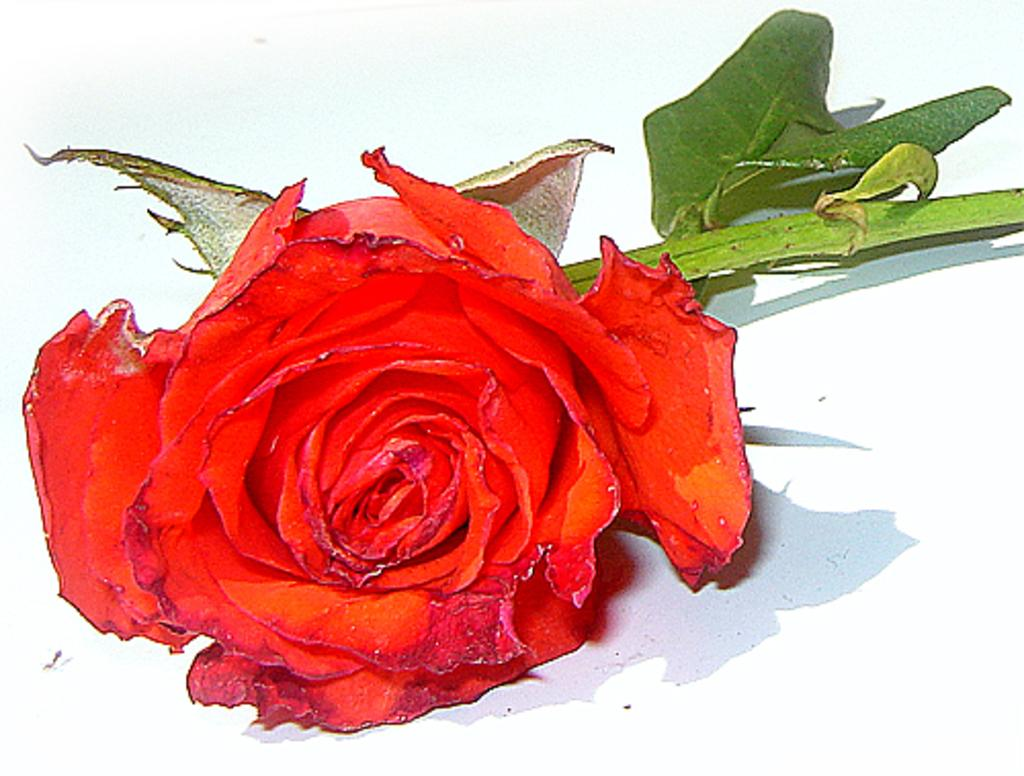What type of flower is in the image? There is a red rose in the image. What color are the leaves in the image? The leaves in the image are green. What connects the flower and leaves in the image? There is a stem in the image. What is the purpose of the glass in the image? There is no glass present in the image. 